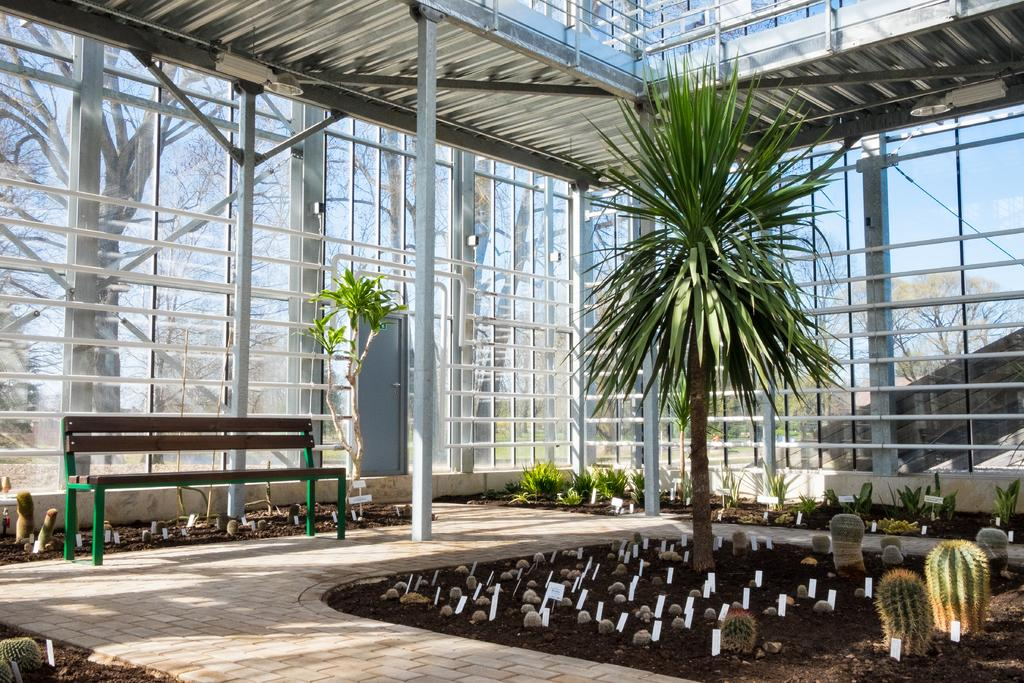What type of seating is visible in the image? There is a bench in the image. What kind of plants can be seen in the image? There are two cactus plants and a green color plant in the image. Can you describe the location of the green color plant? The green color plant is in the middle of the image. What type of account does the bench have in the image? The bench does not have an account in the image; it is a physical object. Is there a plough visible in the image? No, there is no plough present in the image. 